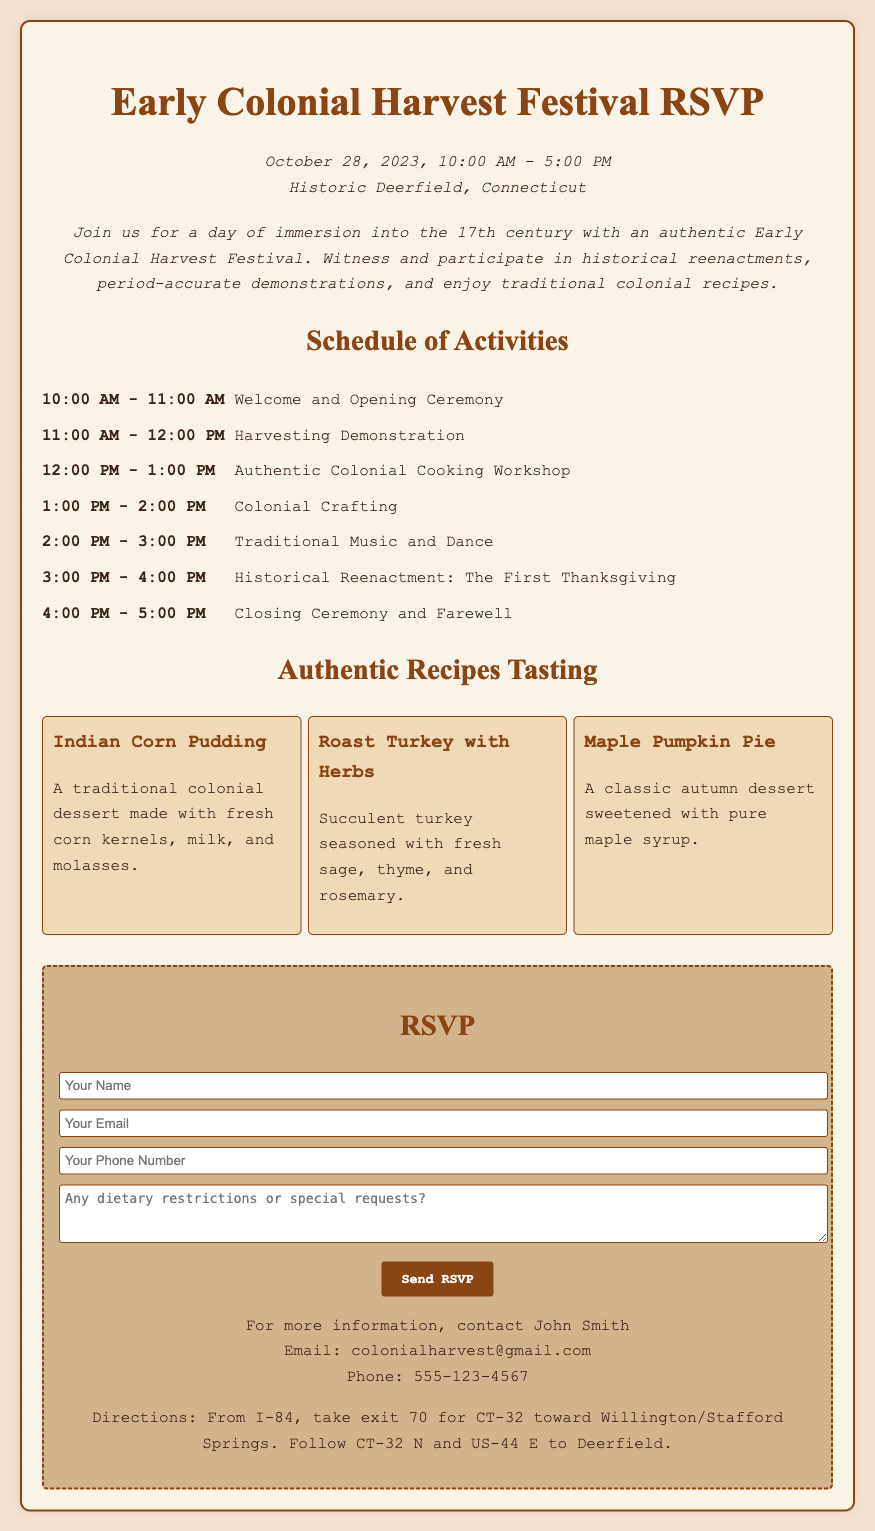What is the date of the festival? The festival is scheduled for October 28, 2023.
Answer: October 28, 2023 What is the time range for the event? The event runs from 10:00 AM to 5:00 PM.
Answer: 10:00 AM - 5:00 PM What is the first activity listed in the schedule? The first activity is the Welcome and Opening Ceremony.
Answer: Welcome and Opening Ceremony What dish is made with fresh corn kernels? The dish made with fresh corn kernels is called Indian Corn Pudding.
Answer: Indian Corn Pudding How long is the Harvesting Demonstration? The Harvesting Demonstration lasts for one hour.
Answer: One hour What type of music will be featured during the festival? The festival will feature Traditional Music and Dance.
Answer: Traditional Music and Dance Who should you contact for more information? For more information, you should contact John Smith.
Answer: John Smith What is the email address provided for inquiries? The email address for more information is colonialharvest@gmail.com.
Answer: colonialharvest@gmail.com What is one dietary option being served at the festival? One of the dietary options served will be Roast Turkey with Herbs.
Answer: Roast Turkey with Herbs 